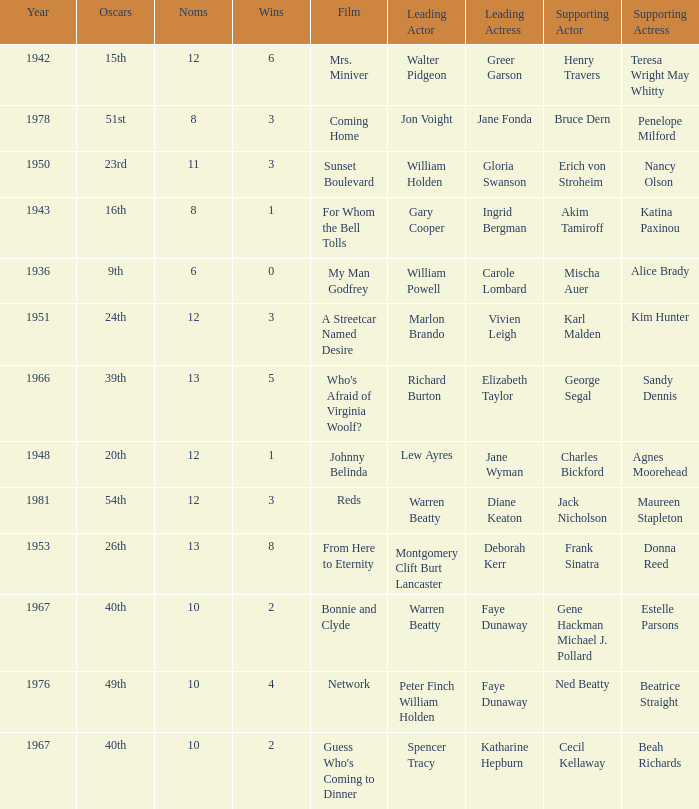Who was the leading actress in a film with Warren Beatty as the leading actor and also at the 40th Oscars? Faye Dunaway. 